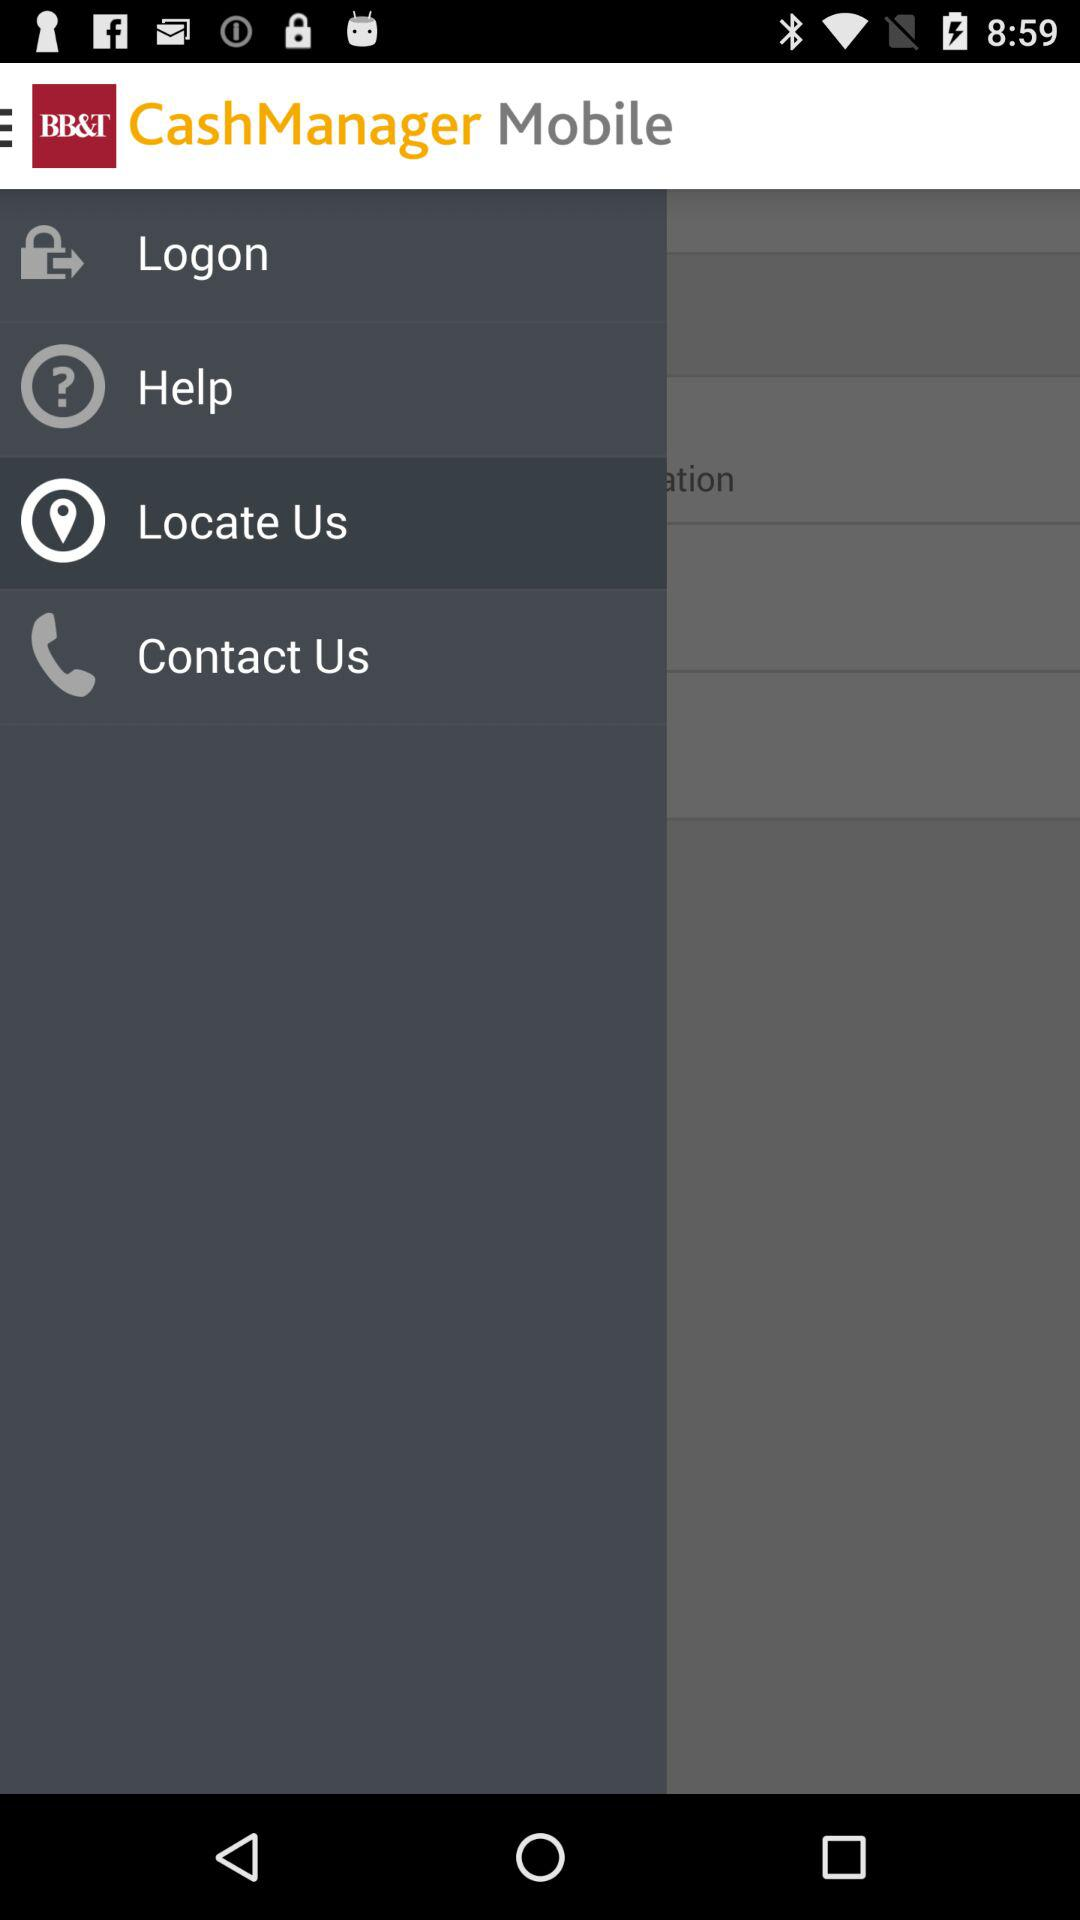What is the application name? The application name is "BB&T CashManager OnLine Mobile". 